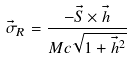Convert formula to latex. <formula><loc_0><loc_0><loc_500><loc_500>\vec { \sigma } _ { R } = \frac { - \vec { S } \times \vec { h } } { M c \sqrt { 1 + \vec { h } ^ { 2 } } }</formula> 